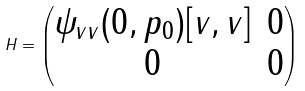<formula> <loc_0><loc_0><loc_500><loc_500>H = \begin{pmatrix} \psi _ { v v } ( 0 , p _ { 0 } ) [ v , v ] & 0 \\ 0 & 0 \end{pmatrix}</formula> 